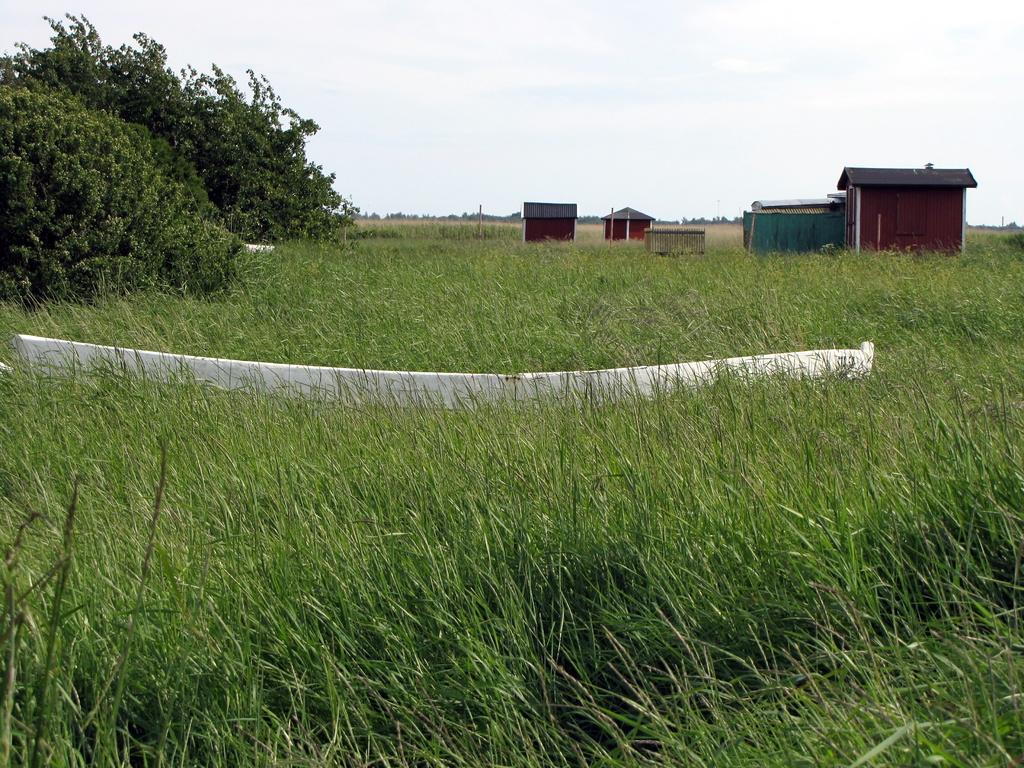In one or two sentences, can you explain what this image depicts? This picture is clicked outside. In the foreground we can see the green grass and a white color object and we can see the trees, cabins and some other objects. In the background we can see the sky. 